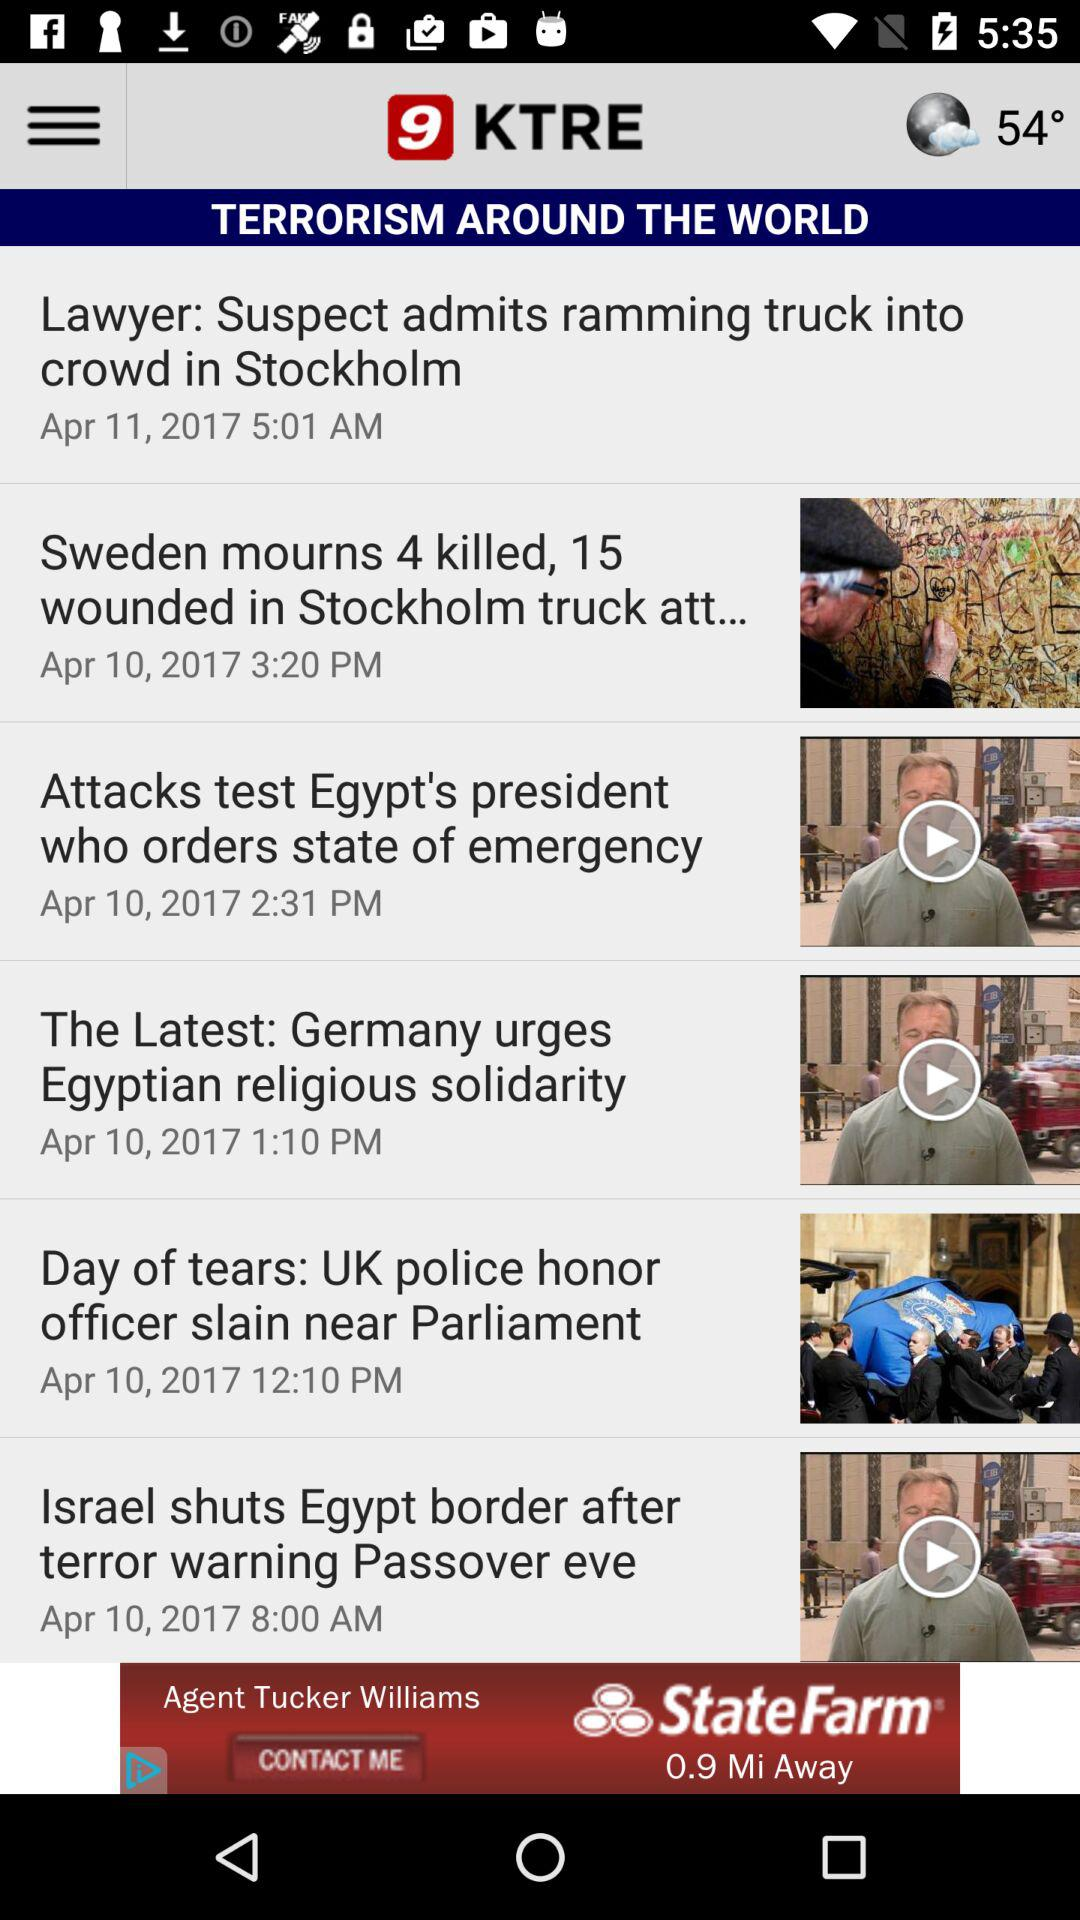What is the published time of the news with the title "Attacks test Egypt's president who orders state of emergency"? The published time of the news with the title "Attacks test Egypt's president who orders state of emergency" is 2:31 p.m. 